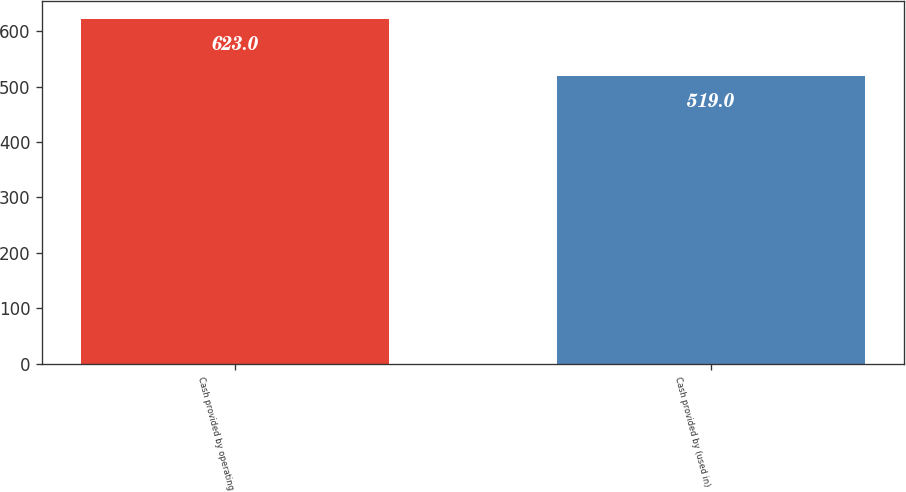Convert chart to OTSL. <chart><loc_0><loc_0><loc_500><loc_500><bar_chart><fcel>Cash provided by operating<fcel>Cash provided by (used in)<nl><fcel>623<fcel>519<nl></chart> 